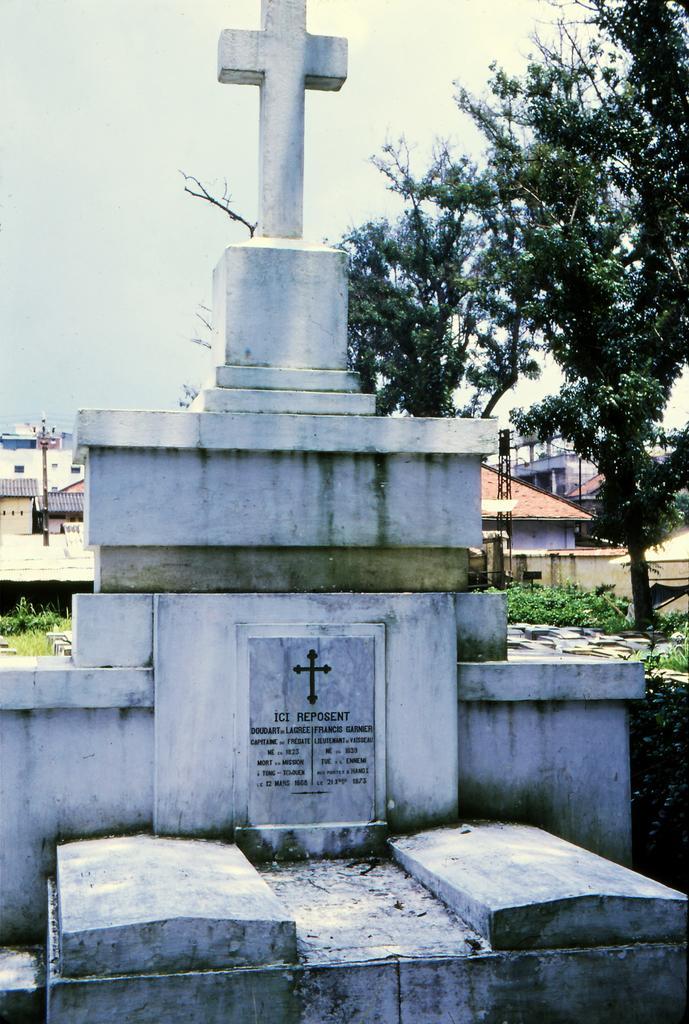How would you summarize this image in a sentence or two? In this picture I can see a headstone, there is a holy cross, there are plants, trees, there are buildings, and in the background there is the sky. 